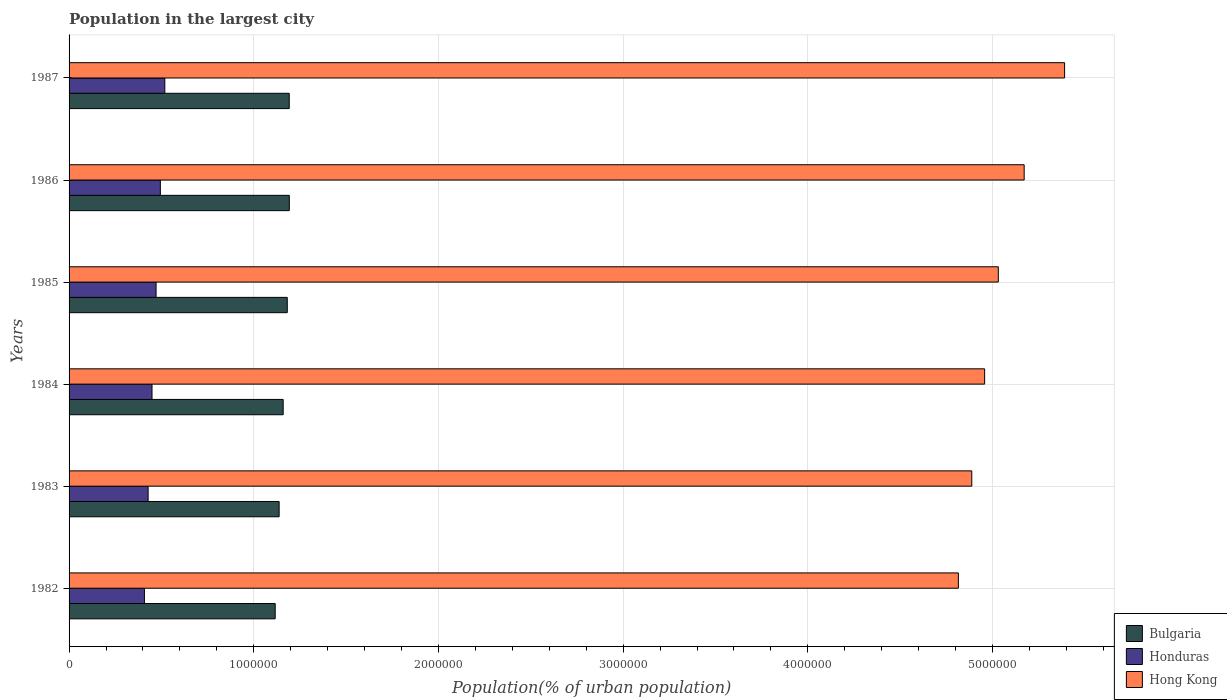How many groups of bars are there?
Ensure brevity in your answer.  6. Are the number of bars per tick equal to the number of legend labels?
Provide a succinct answer. Yes. How many bars are there on the 1st tick from the bottom?
Make the answer very short. 3. What is the label of the 1st group of bars from the top?
Keep it short and to the point. 1987. In how many cases, is the number of bars for a given year not equal to the number of legend labels?
Your answer should be compact. 0. What is the population in the largest city in Honduras in 1985?
Provide a short and direct response. 4.71e+05. Across all years, what is the maximum population in the largest city in Honduras?
Offer a very short reply. 5.18e+05. Across all years, what is the minimum population in the largest city in Honduras?
Your response must be concise. 4.08e+05. In which year was the population in the largest city in Bulgaria maximum?
Keep it short and to the point. 1986. What is the total population in the largest city in Honduras in the graph?
Give a very brief answer. 2.77e+06. What is the difference between the population in the largest city in Honduras in 1983 and that in 1986?
Make the answer very short. -6.62e+04. What is the difference between the population in the largest city in Honduras in 1982 and the population in the largest city in Hong Kong in 1986?
Keep it short and to the point. -4.76e+06. What is the average population in the largest city in Bulgaria per year?
Make the answer very short. 1.16e+06. In the year 1983, what is the difference between the population in the largest city in Hong Kong and population in the largest city in Honduras?
Make the answer very short. 4.46e+06. In how many years, is the population in the largest city in Bulgaria greater than 2600000 %?
Make the answer very short. 0. What is the ratio of the population in the largest city in Honduras in 1982 to that in 1983?
Your response must be concise. 0.95. Is the population in the largest city in Honduras in 1986 less than that in 1987?
Give a very brief answer. Yes. What is the difference between the highest and the second highest population in the largest city in Hong Kong?
Offer a terse response. 2.19e+05. What is the difference between the highest and the lowest population in the largest city in Honduras?
Keep it short and to the point. 1.10e+05. In how many years, is the population in the largest city in Bulgaria greater than the average population in the largest city in Bulgaria taken over all years?
Your answer should be very brief. 3. What does the 2nd bar from the top in 1982 represents?
Your answer should be compact. Honduras. What does the 1st bar from the bottom in 1987 represents?
Keep it short and to the point. Bulgaria. Is it the case that in every year, the sum of the population in the largest city in Bulgaria and population in the largest city in Hong Kong is greater than the population in the largest city in Honduras?
Keep it short and to the point. Yes. How many bars are there?
Offer a very short reply. 18. Are all the bars in the graph horizontal?
Offer a terse response. Yes. How many years are there in the graph?
Provide a short and direct response. 6. What is the difference between two consecutive major ticks on the X-axis?
Keep it short and to the point. 1.00e+06. Are the values on the major ticks of X-axis written in scientific E-notation?
Offer a very short reply. No. Where does the legend appear in the graph?
Offer a terse response. Bottom right. How many legend labels are there?
Ensure brevity in your answer.  3. What is the title of the graph?
Your response must be concise. Population in the largest city. What is the label or title of the X-axis?
Keep it short and to the point. Population(% of urban population). What is the Population(% of urban population) in Bulgaria in 1982?
Your response must be concise. 1.12e+06. What is the Population(% of urban population) in Honduras in 1982?
Keep it short and to the point. 4.08e+05. What is the Population(% of urban population) of Hong Kong in 1982?
Offer a very short reply. 4.82e+06. What is the Population(% of urban population) in Bulgaria in 1983?
Ensure brevity in your answer.  1.14e+06. What is the Population(% of urban population) of Honduras in 1983?
Offer a very short reply. 4.28e+05. What is the Population(% of urban population) in Hong Kong in 1983?
Your response must be concise. 4.89e+06. What is the Population(% of urban population) of Bulgaria in 1984?
Make the answer very short. 1.16e+06. What is the Population(% of urban population) in Honduras in 1984?
Provide a succinct answer. 4.49e+05. What is the Population(% of urban population) of Hong Kong in 1984?
Keep it short and to the point. 4.96e+06. What is the Population(% of urban population) in Bulgaria in 1985?
Your answer should be compact. 1.18e+06. What is the Population(% of urban population) in Honduras in 1985?
Offer a very short reply. 4.71e+05. What is the Population(% of urban population) of Hong Kong in 1985?
Make the answer very short. 5.03e+06. What is the Population(% of urban population) in Bulgaria in 1986?
Keep it short and to the point. 1.19e+06. What is the Population(% of urban population) of Honduras in 1986?
Give a very brief answer. 4.94e+05. What is the Population(% of urban population) in Hong Kong in 1986?
Provide a short and direct response. 5.17e+06. What is the Population(% of urban population) in Bulgaria in 1987?
Keep it short and to the point. 1.19e+06. What is the Population(% of urban population) of Honduras in 1987?
Your answer should be compact. 5.18e+05. What is the Population(% of urban population) of Hong Kong in 1987?
Provide a short and direct response. 5.39e+06. Across all years, what is the maximum Population(% of urban population) in Bulgaria?
Your response must be concise. 1.19e+06. Across all years, what is the maximum Population(% of urban population) in Honduras?
Your answer should be compact. 5.18e+05. Across all years, what is the maximum Population(% of urban population) in Hong Kong?
Offer a very short reply. 5.39e+06. Across all years, what is the minimum Population(% of urban population) in Bulgaria?
Your answer should be compact. 1.12e+06. Across all years, what is the minimum Population(% of urban population) in Honduras?
Your answer should be compact. 4.08e+05. Across all years, what is the minimum Population(% of urban population) of Hong Kong?
Provide a short and direct response. 4.82e+06. What is the total Population(% of urban population) in Bulgaria in the graph?
Provide a short and direct response. 6.98e+06. What is the total Population(% of urban population) in Honduras in the graph?
Provide a succinct answer. 2.77e+06. What is the total Population(% of urban population) of Hong Kong in the graph?
Keep it short and to the point. 3.03e+07. What is the difference between the Population(% of urban population) in Bulgaria in 1982 and that in 1983?
Give a very brief answer. -2.14e+04. What is the difference between the Population(% of urban population) in Honduras in 1982 and that in 1983?
Your answer should be very brief. -2.00e+04. What is the difference between the Population(% of urban population) in Hong Kong in 1982 and that in 1983?
Your answer should be very brief. -7.26e+04. What is the difference between the Population(% of urban population) of Bulgaria in 1982 and that in 1984?
Give a very brief answer. -4.33e+04. What is the difference between the Population(% of urban population) of Honduras in 1982 and that in 1984?
Give a very brief answer. -4.11e+04. What is the difference between the Population(% of urban population) of Hong Kong in 1982 and that in 1984?
Provide a succinct answer. -1.42e+05. What is the difference between the Population(% of urban population) of Bulgaria in 1982 and that in 1985?
Your response must be concise. -6.55e+04. What is the difference between the Population(% of urban population) in Honduras in 1982 and that in 1985?
Offer a terse response. -6.31e+04. What is the difference between the Population(% of urban population) in Hong Kong in 1982 and that in 1985?
Your response must be concise. -2.16e+05. What is the difference between the Population(% of urban population) in Bulgaria in 1982 and that in 1986?
Your answer should be very brief. -7.66e+04. What is the difference between the Population(% of urban population) of Honduras in 1982 and that in 1986?
Give a very brief answer. -8.62e+04. What is the difference between the Population(% of urban population) of Hong Kong in 1982 and that in 1986?
Offer a very short reply. -3.56e+05. What is the difference between the Population(% of urban population) of Bulgaria in 1982 and that in 1987?
Give a very brief answer. -7.61e+04. What is the difference between the Population(% of urban population) in Honduras in 1982 and that in 1987?
Provide a short and direct response. -1.10e+05. What is the difference between the Population(% of urban population) of Hong Kong in 1982 and that in 1987?
Your answer should be compact. -5.75e+05. What is the difference between the Population(% of urban population) of Bulgaria in 1983 and that in 1984?
Ensure brevity in your answer.  -2.19e+04. What is the difference between the Population(% of urban population) in Honduras in 1983 and that in 1984?
Offer a terse response. -2.10e+04. What is the difference between the Population(% of urban population) of Hong Kong in 1983 and that in 1984?
Your answer should be very brief. -6.96e+04. What is the difference between the Population(% of urban population) of Bulgaria in 1983 and that in 1985?
Your answer should be very brief. -4.41e+04. What is the difference between the Population(% of urban population) of Honduras in 1983 and that in 1985?
Your response must be concise. -4.30e+04. What is the difference between the Population(% of urban population) in Hong Kong in 1983 and that in 1985?
Your answer should be compact. -1.44e+05. What is the difference between the Population(% of urban population) in Bulgaria in 1983 and that in 1986?
Keep it short and to the point. -5.51e+04. What is the difference between the Population(% of urban population) in Honduras in 1983 and that in 1986?
Provide a succinct answer. -6.62e+04. What is the difference between the Population(% of urban population) in Hong Kong in 1983 and that in 1986?
Provide a succinct answer. -2.84e+05. What is the difference between the Population(% of urban population) of Bulgaria in 1983 and that in 1987?
Offer a terse response. -5.47e+04. What is the difference between the Population(% of urban population) of Honduras in 1983 and that in 1987?
Provide a succinct answer. -9.04e+04. What is the difference between the Population(% of urban population) of Hong Kong in 1983 and that in 1987?
Offer a very short reply. -5.03e+05. What is the difference between the Population(% of urban population) in Bulgaria in 1984 and that in 1985?
Your answer should be compact. -2.22e+04. What is the difference between the Population(% of urban population) in Honduras in 1984 and that in 1985?
Provide a succinct answer. -2.20e+04. What is the difference between the Population(% of urban population) in Hong Kong in 1984 and that in 1985?
Provide a succinct answer. -7.40e+04. What is the difference between the Population(% of urban population) of Bulgaria in 1984 and that in 1986?
Offer a very short reply. -3.33e+04. What is the difference between the Population(% of urban population) of Honduras in 1984 and that in 1986?
Offer a terse response. -4.51e+04. What is the difference between the Population(% of urban population) in Hong Kong in 1984 and that in 1986?
Make the answer very short. -2.14e+05. What is the difference between the Population(% of urban population) in Bulgaria in 1984 and that in 1987?
Offer a terse response. -3.28e+04. What is the difference between the Population(% of urban population) of Honduras in 1984 and that in 1987?
Provide a succinct answer. -6.94e+04. What is the difference between the Population(% of urban population) of Hong Kong in 1984 and that in 1987?
Your answer should be compact. -4.33e+05. What is the difference between the Population(% of urban population) in Bulgaria in 1985 and that in 1986?
Offer a very short reply. -1.11e+04. What is the difference between the Population(% of urban population) of Honduras in 1985 and that in 1986?
Give a very brief answer. -2.31e+04. What is the difference between the Population(% of urban population) in Hong Kong in 1985 and that in 1986?
Give a very brief answer. -1.40e+05. What is the difference between the Population(% of urban population) in Bulgaria in 1985 and that in 1987?
Provide a short and direct response. -1.06e+04. What is the difference between the Population(% of urban population) in Honduras in 1985 and that in 1987?
Keep it short and to the point. -4.74e+04. What is the difference between the Population(% of urban population) of Hong Kong in 1985 and that in 1987?
Give a very brief answer. -3.59e+05. What is the difference between the Population(% of urban population) in Bulgaria in 1986 and that in 1987?
Keep it short and to the point. 454. What is the difference between the Population(% of urban population) in Honduras in 1986 and that in 1987?
Give a very brief answer. -2.42e+04. What is the difference between the Population(% of urban population) in Hong Kong in 1986 and that in 1987?
Make the answer very short. -2.19e+05. What is the difference between the Population(% of urban population) in Bulgaria in 1982 and the Population(% of urban population) in Honduras in 1983?
Provide a short and direct response. 6.88e+05. What is the difference between the Population(% of urban population) of Bulgaria in 1982 and the Population(% of urban population) of Hong Kong in 1983?
Make the answer very short. -3.77e+06. What is the difference between the Population(% of urban population) in Honduras in 1982 and the Population(% of urban population) in Hong Kong in 1983?
Provide a short and direct response. -4.48e+06. What is the difference between the Population(% of urban population) of Bulgaria in 1982 and the Population(% of urban population) of Honduras in 1984?
Your response must be concise. 6.67e+05. What is the difference between the Population(% of urban population) in Bulgaria in 1982 and the Population(% of urban population) in Hong Kong in 1984?
Your response must be concise. -3.84e+06. What is the difference between the Population(% of urban population) of Honduras in 1982 and the Population(% of urban population) of Hong Kong in 1984?
Your answer should be very brief. -4.55e+06. What is the difference between the Population(% of urban population) of Bulgaria in 1982 and the Population(% of urban population) of Honduras in 1985?
Give a very brief answer. 6.45e+05. What is the difference between the Population(% of urban population) in Bulgaria in 1982 and the Population(% of urban population) in Hong Kong in 1985?
Your answer should be very brief. -3.92e+06. What is the difference between the Population(% of urban population) of Honduras in 1982 and the Population(% of urban population) of Hong Kong in 1985?
Offer a very short reply. -4.62e+06. What is the difference between the Population(% of urban population) of Bulgaria in 1982 and the Population(% of urban population) of Honduras in 1986?
Offer a terse response. 6.22e+05. What is the difference between the Population(% of urban population) of Bulgaria in 1982 and the Population(% of urban population) of Hong Kong in 1986?
Offer a terse response. -4.06e+06. What is the difference between the Population(% of urban population) in Honduras in 1982 and the Population(% of urban population) in Hong Kong in 1986?
Offer a terse response. -4.76e+06. What is the difference between the Population(% of urban population) of Bulgaria in 1982 and the Population(% of urban population) of Honduras in 1987?
Give a very brief answer. 5.98e+05. What is the difference between the Population(% of urban population) in Bulgaria in 1982 and the Population(% of urban population) in Hong Kong in 1987?
Provide a short and direct response. -4.27e+06. What is the difference between the Population(% of urban population) of Honduras in 1982 and the Population(% of urban population) of Hong Kong in 1987?
Your answer should be compact. -4.98e+06. What is the difference between the Population(% of urban population) of Bulgaria in 1983 and the Population(% of urban population) of Honduras in 1984?
Your answer should be compact. 6.88e+05. What is the difference between the Population(% of urban population) in Bulgaria in 1983 and the Population(% of urban population) in Hong Kong in 1984?
Give a very brief answer. -3.82e+06. What is the difference between the Population(% of urban population) of Honduras in 1983 and the Population(% of urban population) of Hong Kong in 1984?
Provide a succinct answer. -4.53e+06. What is the difference between the Population(% of urban population) of Bulgaria in 1983 and the Population(% of urban population) of Honduras in 1985?
Keep it short and to the point. 6.66e+05. What is the difference between the Population(% of urban population) in Bulgaria in 1983 and the Population(% of urban population) in Hong Kong in 1985?
Offer a very short reply. -3.89e+06. What is the difference between the Population(% of urban population) of Honduras in 1983 and the Population(% of urban population) of Hong Kong in 1985?
Provide a short and direct response. -4.60e+06. What is the difference between the Population(% of urban population) of Bulgaria in 1983 and the Population(% of urban population) of Honduras in 1986?
Ensure brevity in your answer.  6.43e+05. What is the difference between the Population(% of urban population) of Bulgaria in 1983 and the Population(% of urban population) of Hong Kong in 1986?
Offer a very short reply. -4.03e+06. What is the difference between the Population(% of urban population) in Honduras in 1983 and the Population(% of urban population) in Hong Kong in 1986?
Provide a short and direct response. -4.74e+06. What is the difference between the Population(% of urban population) in Bulgaria in 1983 and the Population(% of urban population) in Honduras in 1987?
Keep it short and to the point. 6.19e+05. What is the difference between the Population(% of urban population) of Bulgaria in 1983 and the Population(% of urban population) of Hong Kong in 1987?
Your answer should be very brief. -4.25e+06. What is the difference between the Population(% of urban population) in Honduras in 1983 and the Population(% of urban population) in Hong Kong in 1987?
Provide a short and direct response. -4.96e+06. What is the difference between the Population(% of urban population) in Bulgaria in 1984 and the Population(% of urban population) in Honduras in 1985?
Provide a succinct answer. 6.88e+05. What is the difference between the Population(% of urban population) in Bulgaria in 1984 and the Population(% of urban population) in Hong Kong in 1985?
Your answer should be very brief. -3.87e+06. What is the difference between the Population(% of urban population) in Honduras in 1984 and the Population(% of urban population) in Hong Kong in 1985?
Your answer should be compact. -4.58e+06. What is the difference between the Population(% of urban population) in Bulgaria in 1984 and the Population(% of urban population) in Honduras in 1986?
Provide a succinct answer. 6.65e+05. What is the difference between the Population(% of urban population) of Bulgaria in 1984 and the Population(% of urban population) of Hong Kong in 1986?
Give a very brief answer. -4.01e+06. What is the difference between the Population(% of urban population) of Honduras in 1984 and the Population(% of urban population) of Hong Kong in 1986?
Provide a succinct answer. -4.72e+06. What is the difference between the Population(% of urban population) of Bulgaria in 1984 and the Population(% of urban population) of Honduras in 1987?
Keep it short and to the point. 6.41e+05. What is the difference between the Population(% of urban population) in Bulgaria in 1984 and the Population(% of urban population) in Hong Kong in 1987?
Your response must be concise. -4.23e+06. What is the difference between the Population(% of urban population) of Honduras in 1984 and the Population(% of urban population) of Hong Kong in 1987?
Provide a short and direct response. -4.94e+06. What is the difference between the Population(% of urban population) of Bulgaria in 1985 and the Population(% of urban population) of Honduras in 1986?
Your response must be concise. 6.87e+05. What is the difference between the Population(% of urban population) in Bulgaria in 1985 and the Population(% of urban population) in Hong Kong in 1986?
Your answer should be very brief. -3.99e+06. What is the difference between the Population(% of urban population) of Honduras in 1985 and the Population(% of urban population) of Hong Kong in 1986?
Make the answer very short. -4.70e+06. What is the difference between the Population(% of urban population) in Bulgaria in 1985 and the Population(% of urban population) in Honduras in 1987?
Make the answer very short. 6.63e+05. What is the difference between the Population(% of urban population) of Bulgaria in 1985 and the Population(% of urban population) of Hong Kong in 1987?
Your answer should be very brief. -4.21e+06. What is the difference between the Population(% of urban population) in Honduras in 1985 and the Population(% of urban population) in Hong Kong in 1987?
Keep it short and to the point. -4.92e+06. What is the difference between the Population(% of urban population) in Bulgaria in 1986 and the Population(% of urban population) in Honduras in 1987?
Offer a terse response. 6.74e+05. What is the difference between the Population(% of urban population) of Bulgaria in 1986 and the Population(% of urban population) of Hong Kong in 1987?
Make the answer very short. -4.20e+06. What is the difference between the Population(% of urban population) of Honduras in 1986 and the Population(% of urban population) of Hong Kong in 1987?
Provide a short and direct response. -4.90e+06. What is the average Population(% of urban population) in Bulgaria per year?
Your answer should be very brief. 1.16e+06. What is the average Population(% of urban population) of Honduras per year?
Offer a very short reply. 4.61e+05. What is the average Population(% of urban population) in Hong Kong per year?
Provide a short and direct response. 5.04e+06. In the year 1982, what is the difference between the Population(% of urban population) in Bulgaria and Population(% of urban population) in Honduras?
Provide a short and direct response. 7.08e+05. In the year 1982, what is the difference between the Population(% of urban population) of Bulgaria and Population(% of urban population) of Hong Kong?
Your answer should be very brief. -3.70e+06. In the year 1982, what is the difference between the Population(% of urban population) of Honduras and Population(% of urban population) of Hong Kong?
Your answer should be very brief. -4.41e+06. In the year 1983, what is the difference between the Population(% of urban population) of Bulgaria and Population(% of urban population) of Honduras?
Your answer should be compact. 7.09e+05. In the year 1983, what is the difference between the Population(% of urban population) in Bulgaria and Population(% of urban population) in Hong Kong?
Keep it short and to the point. -3.75e+06. In the year 1983, what is the difference between the Population(% of urban population) of Honduras and Population(% of urban population) of Hong Kong?
Provide a short and direct response. -4.46e+06. In the year 1984, what is the difference between the Population(% of urban population) in Bulgaria and Population(% of urban population) in Honduras?
Provide a short and direct response. 7.10e+05. In the year 1984, what is the difference between the Population(% of urban population) in Bulgaria and Population(% of urban population) in Hong Kong?
Keep it short and to the point. -3.80e+06. In the year 1984, what is the difference between the Population(% of urban population) of Honduras and Population(% of urban population) of Hong Kong?
Provide a succinct answer. -4.51e+06. In the year 1985, what is the difference between the Population(% of urban population) of Bulgaria and Population(% of urban population) of Honduras?
Ensure brevity in your answer.  7.10e+05. In the year 1985, what is the difference between the Population(% of urban population) of Bulgaria and Population(% of urban population) of Hong Kong?
Your response must be concise. -3.85e+06. In the year 1985, what is the difference between the Population(% of urban population) in Honduras and Population(% of urban population) in Hong Kong?
Your answer should be very brief. -4.56e+06. In the year 1986, what is the difference between the Population(% of urban population) in Bulgaria and Population(% of urban population) in Honduras?
Your answer should be compact. 6.98e+05. In the year 1986, what is the difference between the Population(% of urban population) of Bulgaria and Population(% of urban population) of Hong Kong?
Offer a very short reply. -3.98e+06. In the year 1986, what is the difference between the Population(% of urban population) of Honduras and Population(% of urban population) of Hong Kong?
Your response must be concise. -4.68e+06. In the year 1987, what is the difference between the Population(% of urban population) of Bulgaria and Population(% of urban population) of Honduras?
Offer a very short reply. 6.74e+05. In the year 1987, what is the difference between the Population(% of urban population) in Bulgaria and Population(% of urban population) in Hong Kong?
Provide a succinct answer. -4.20e+06. In the year 1987, what is the difference between the Population(% of urban population) of Honduras and Population(% of urban population) of Hong Kong?
Your answer should be very brief. -4.87e+06. What is the ratio of the Population(% of urban population) of Bulgaria in 1982 to that in 1983?
Offer a terse response. 0.98. What is the ratio of the Population(% of urban population) in Honduras in 1982 to that in 1983?
Keep it short and to the point. 0.95. What is the ratio of the Population(% of urban population) of Hong Kong in 1982 to that in 1983?
Offer a very short reply. 0.99. What is the ratio of the Population(% of urban population) in Bulgaria in 1982 to that in 1984?
Offer a very short reply. 0.96. What is the ratio of the Population(% of urban population) of Honduras in 1982 to that in 1984?
Offer a very short reply. 0.91. What is the ratio of the Population(% of urban population) of Hong Kong in 1982 to that in 1984?
Offer a terse response. 0.97. What is the ratio of the Population(% of urban population) of Bulgaria in 1982 to that in 1985?
Offer a terse response. 0.94. What is the ratio of the Population(% of urban population) in Honduras in 1982 to that in 1985?
Offer a terse response. 0.87. What is the ratio of the Population(% of urban population) in Bulgaria in 1982 to that in 1986?
Provide a succinct answer. 0.94. What is the ratio of the Population(% of urban population) of Honduras in 1982 to that in 1986?
Keep it short and to the point. 0.83. What is the ratio of the Population(% of urban population) of Hong Kong in 1982 to that in 1986?
Give a very brief answer. 0.93. What is the ratio of the Population(% of urban population) of Bulgaria in 1982 to that in 1987?
Your response must be concise. 0.94. What is the ratio of the Population(% of urban population) in Honduras in 1982 to that in 1987?
Offer a terse response. 0.79. What is the ratio of the Population(% of urban population) in Hong Kong in 1982 to that in 1987?
Ensure brevity in your answer.  0.89. What is the ratio of the Population(% of urban population) in Bulgaria in 1983 to that in 1984?
Provide a short and direct response. 0.98. What is the ratio of the Population(% of urban population) in Honduras in 1983 to that in 1984?
Keep it short and to the point. 0.95. What is the ratio of the Population(% of urban population) in Bulgaria in 1983 to that in 1985?
Your answer should be very brief. 0.96. What is the ratio of the Population(% of urban population) of Honduras in 1983 to that in 1985?
Your answer should be compact. 0.91. What is the ratio of the Population(% of urban population) of Hong Kong in 1983 to that in 1985?
Your answer should be very brief. 0.97. What is the ratio of the Population(% of urban population) of Bulgaria in 1983 to that in 1986?
Ensure brevity in your answer.  0.95. What is the ratio of the Population(% of urban population) in Honduras in 1983 to that in 1986?
Give a very brief answer. 0.87. What is the ratio of the Population(% of urban population) in Hong Kong in 1983 to that in 1986?
Make the answer very short. 0.95. What is the ratio of the Population(% of urban population) in Bulgaria in 1983 to that in 1987?
Your response must be concise. 0.95. What is the ratio of the Population(% of urban population) of Honduras in 1983 to that in 1987?
Make the answer very short. 0.83. What is the ratio of the Population(% of urban population) of Hong Kong in 1983 to that in 1987?
Provide a short and direct response. 0.91. What is the ratio of the Population(% of urban population) of Bulgaria in 1984 to that in 1985?
Provide a succinct answer. 0.98. What is the ratio of the Population(% of urban population) of Honduras in 1984 to that in 1985?
Offer a terse response. 0.95. What is the ratio of the Population(% of urban population) of Bulgaria in 1984 to that in 1986?
Provide a short and direct response. 0.97. What is the ratio of the Population(% of urban population) in Honduras in 1984 to that in 1986?
Offer a very short reply. 0.91. What is the ratio of the Population(% of urban population) of Hong Kong in 1984 to that in 1986?
Your answer should be compact. 0.96. What is the ratio of the Population(% of urban population) in Bulgaria in 1984 to that in 1987?
Keep it short and to the point. 0.97. What is the ratio of the Population(% of urban population) in Honduras in 1984 to that in 1987?
Make the answer very short. 0.87. What is the ratio of the Population(% of urban population) in Hong Kong in 1984 to that in 1987?
Give a very brief answer. 0.92. What is the ratio of the Population(% of urban population) in Honduras in 1985 to that in 1986?
Your response must be concise. 0.95. What is the ratio of the Population(% of urban population) of Hong Kong in 1985 to that in 1986?
Your answer should be very brief. 0.97. What is the ratio of the Population(% of urban population) in Honduras in 1985 to that in 1987?
Keep it short and to the point. 0.91. What is the ratio of the Population(% of urban population) in Hong Kong in 1985 to that in 1987?
Your answer should be very brief. 0.93. What is the ratio of the Population(% of urban population) in Honduras in 1986 to that in 1987?
Your answer should be compact. 0.95. What is the ratio of the Population(% of urban population) in Hong Kong in 1986 to that in 1987?
Offer a very short reply. 0.96. What is the difference between the highest and the second highest Population(% of urban population) of Bulgaria?
Ensure brevity in your answer.  454. What is the difference between the highest and the second highest Population(% of urban population) of Honduras?
Ensure brevity in your answer.  2.42e+04. What is the difference between the highest and the second highest Population(% of urban population) in Hong Kong?
Provide a succinct answer. 2.19e+05. What is the difference between the highest and the lowest Population(% of urban population) in Bulgaria?
Offer a very short reply. 7.66e+04. What is the difference between the highest and the lowest Population(% of urban population) in Honduras?
Your response must be concise. 1.10e+05. What is the difference between the highest and the lowest Population(% of urban population) of Hong Kong?
Keep it short and to the point. 5.75e+05. 